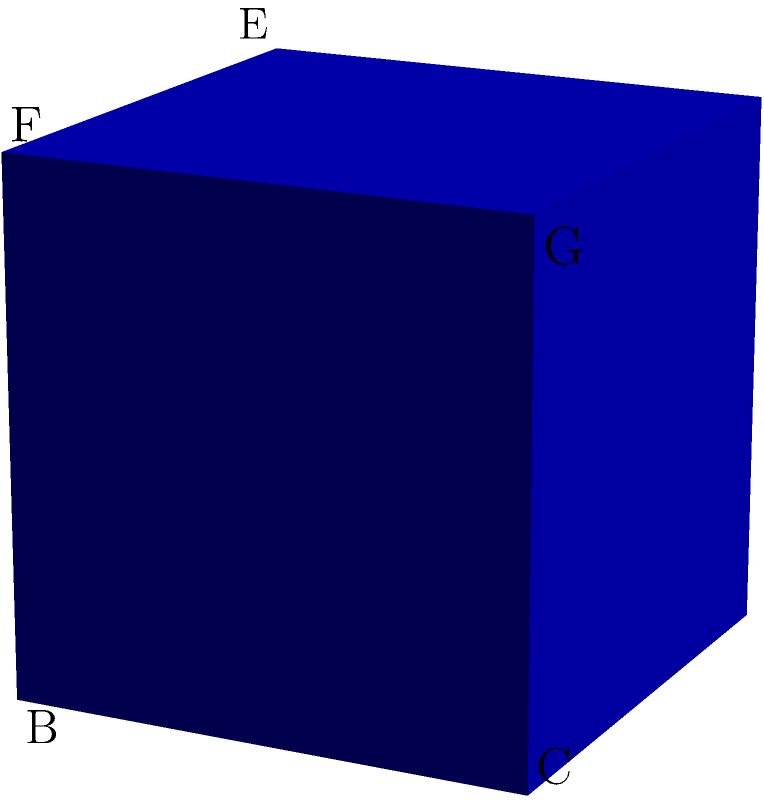A unit cube ABCDEFGH is cut by a horizontal plane at a height of 0.7 units from its base. What shape is the cross-section formed by this cut? Let's approach this step-by-step:

1) First, we need to understand what a unit cube is. It's a cube with sides of length 1 unit.

2) The cutting plane is horizontal and at a height of 0.7 units from the base. This means it's parallel to the base of the cube.

3) When a cube is cut by a plane parallel to its base:
   - The cross-section will always be a square, regardless of the height of the cut.
   - This is because all vertical edges of the cube are intersected at the same height.

4) The size of this square cross-section can be calculated, but it's not necessary for determining the shape.

5) If the cutting plane were at an angle (not parallel to the base), we might get other shapes like rectangles, parallelograms, or even hexagons. But in this case, it's parallel to the base.

Therefore, the cross-section formed by this horizontal cut will be a square.
Answer: Square 